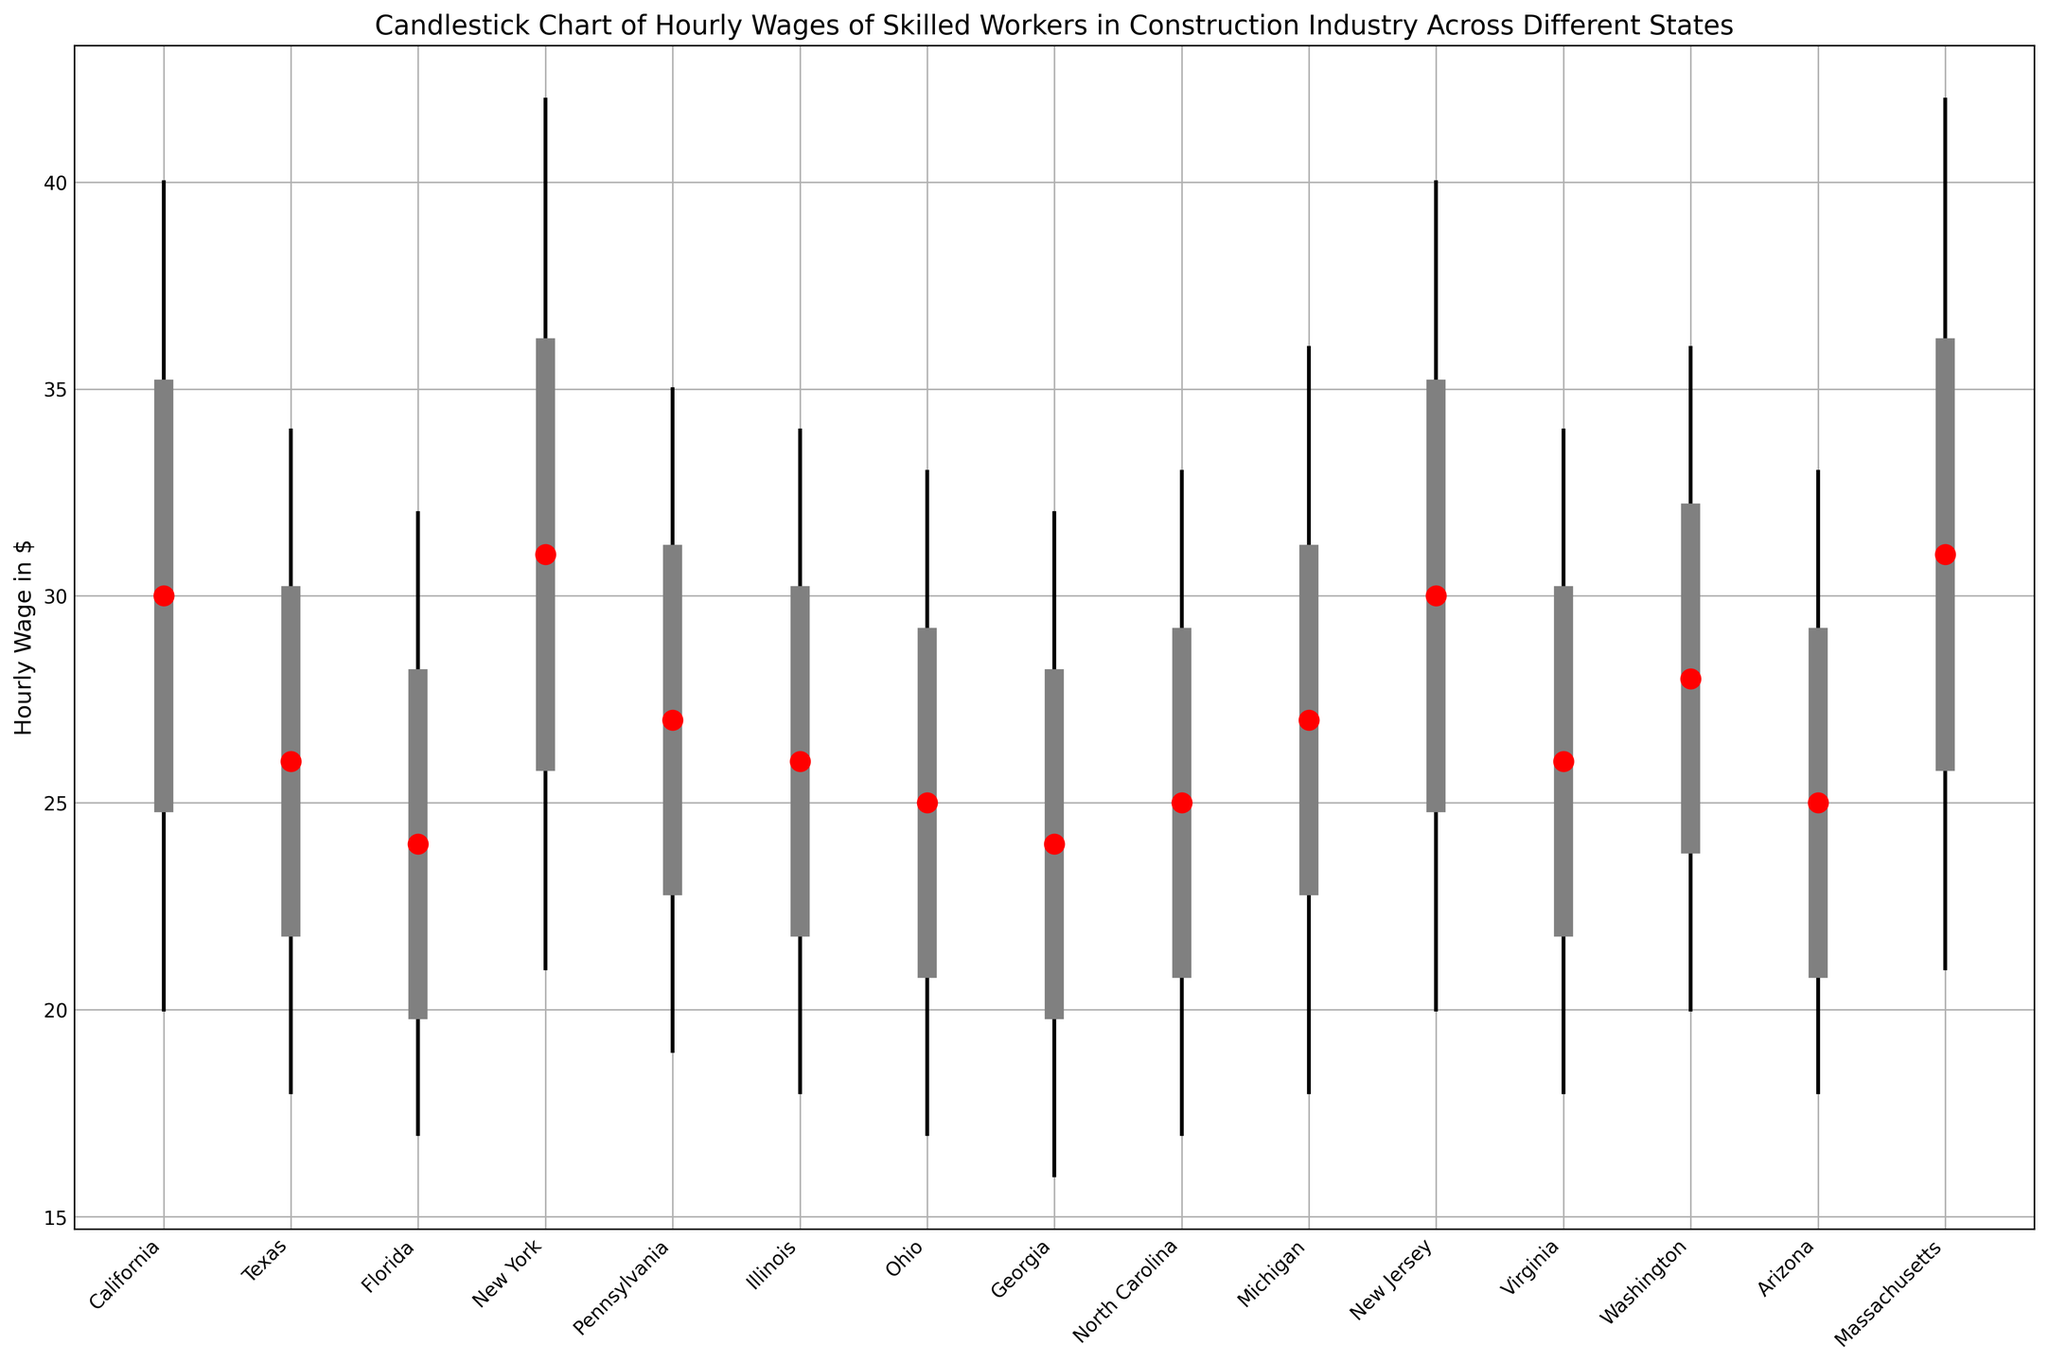What's the median hourly wage for skilled workers in New York? Look at the red dot on the candlestick chart for New York and note its position on the y-axis.
Answer: 31 Which state has the highest maximum hourly wage? Check the topmost point of the candlesticks across states and identify the state with the highest point.
Answer: New York and Massachusetts What is the range of hourly wages in California? Subtract the minimum hourly wage from the maximum hourly wage for California.
Answer: 20 (40 - 20) Compare the median hourly wages between Pennsylvania and Ohio. Which state has a higher median wage? Look at the red dots for both Pennsylvania and Ohio and compare their positions.
Answer: Pennsylvania Which state has the largest interquartile range (IQR) of hourly wages? The IQR is the difference between the third quartile (q3) and the first quartile (q1). Calculate and compare for each state.
Answer: California, New York, and Massachusetts (IQR is 10) How does the hourly wage variability between Texas and Illinois compare? Look at the length of the candlesticks (min to max) for Texas and Illinois.
Answer: They have the same range of 16 dollars (34 - 18) Identify the state with the smallest median hourly wage. Check the positions of the red dots and find the lowest one.
Answer: Georgia (24) Compare the maximum hourly wage of Washington and Virginia. Which state has a higher maximum? Look at the topmost points of the candlesticks for both Washington and Virginia and compare.
Answer: Washington Calculate the average maximum hourly wage across all states. Sum the maximum hourly wages of all states and divide by the number of states. (40 + 34 + 32 + 42 + 35 + 34 + 33 + 32 + 33 + 36 + 40 + 34 + 36 + 33 + 42 = 526; 526/15 = 35.07)
Answer: 35.07 Which state shows the smallest range between the first and third quartiles (Q1 to Q3)? Subtract the first quartile from the third quartile for each state and find the smallest value. (Q3 - Q1)
Answer: Arizona, Florida, Georgia, and Virginia (8) 